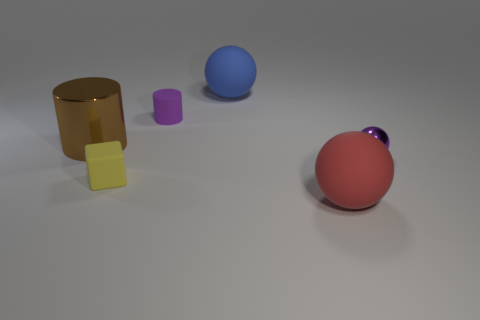Subtract all rubber spheres. How many spheres are left? 1 Add 2 red things. How many objects exist? 8 Subtract all cylinders. How many objects are left? 4 Add 1 tiny purple cylinders. How many tiny purple cylinders exist? 2 Subtract 1 purple cylinders. How many objects are left? 5 Subtract all tiny cyan metal blocks. Subtract all small yellow blocks. How many objects are left? 5 Add 4 small matte cylinders. How many small matte cylinders are left? 5 